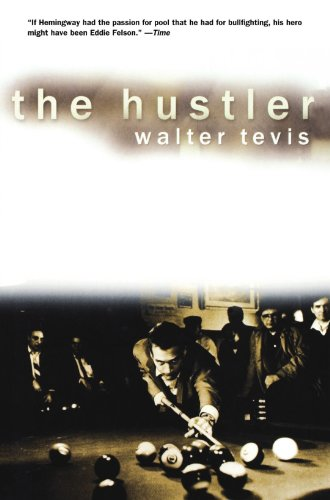What themes are explored in this book? 'The Hustler' deeply explores themes of ambition, obsession, and redemption. The narrative delves into how personal vices and virtues can lead both to downfall and personal growth. 